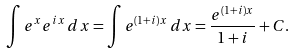<formula> <loc_0><loc_0><loc_500><loc_500>\int e ^ { x } e ^ { i x } \, d x = \int e ^ { ( 1 + i ) x } \, d x = { \frac { e ^ { ( 1 + i ) x } } { 1 + i } } + C .</formula> 